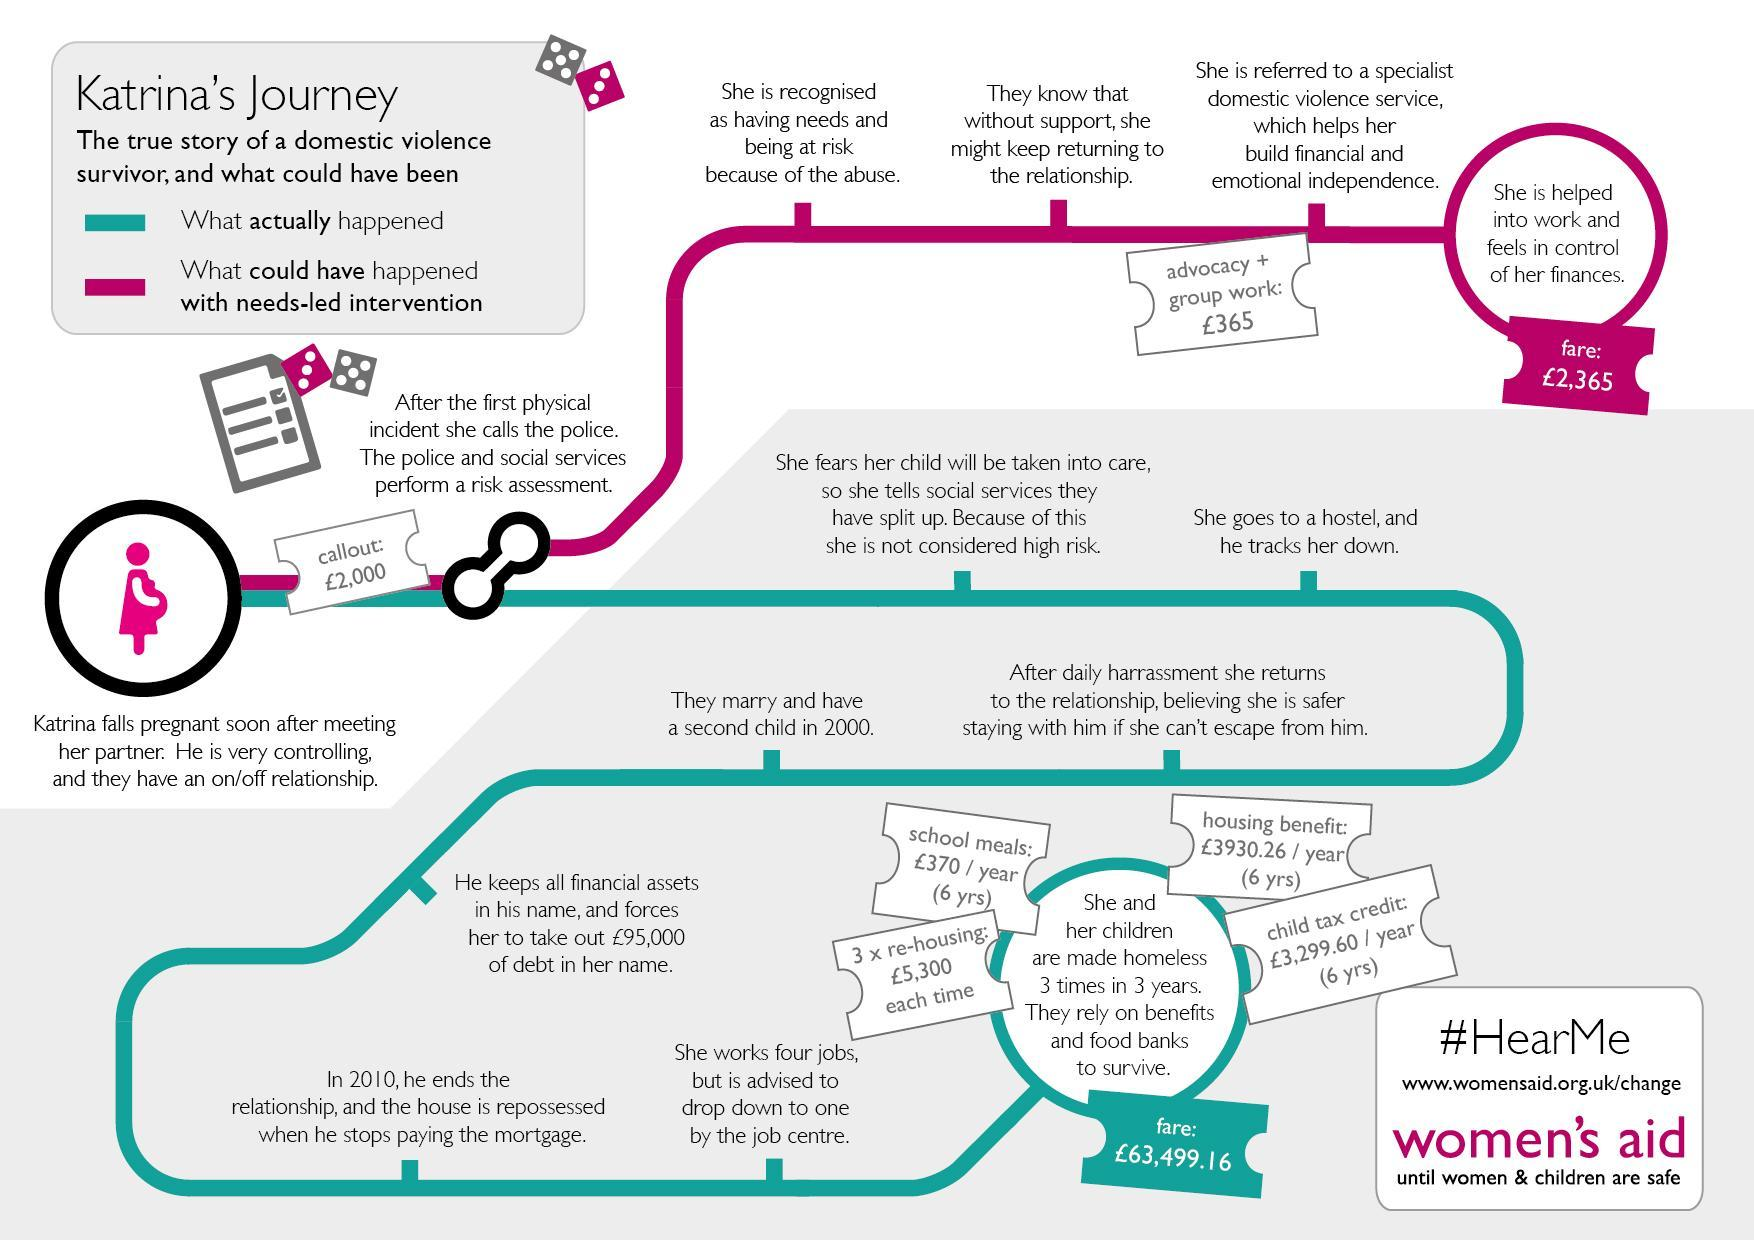What could have been the first step done when police and social services perform a risk assessment
Answer the question with a short phrase. She is recognised as having needs and being at risk because of the abuse Who tracks her down when she goes to hostel her partner How much higher was the actual expense in pound than the expense that could have been incurred 61134.16 What was the total cost in pounds for school meals for 6 years 2220 What is the cost of re-housing thrice in pounds 15900 